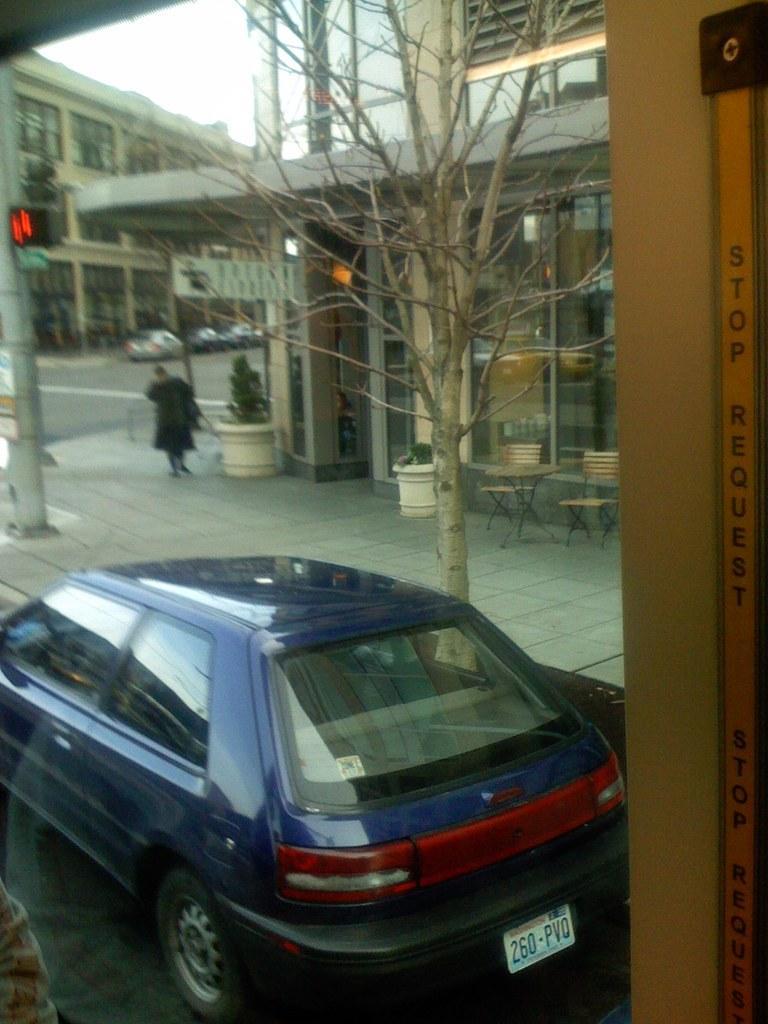Describe this image in one or two sentences. In the center of the image there is a car. In the foreground of the image there is a glass wall through which we can see buildings,tree,road,vehicles on the road. There is a pole. There are chairs to the right side of the image. There is a tree. 